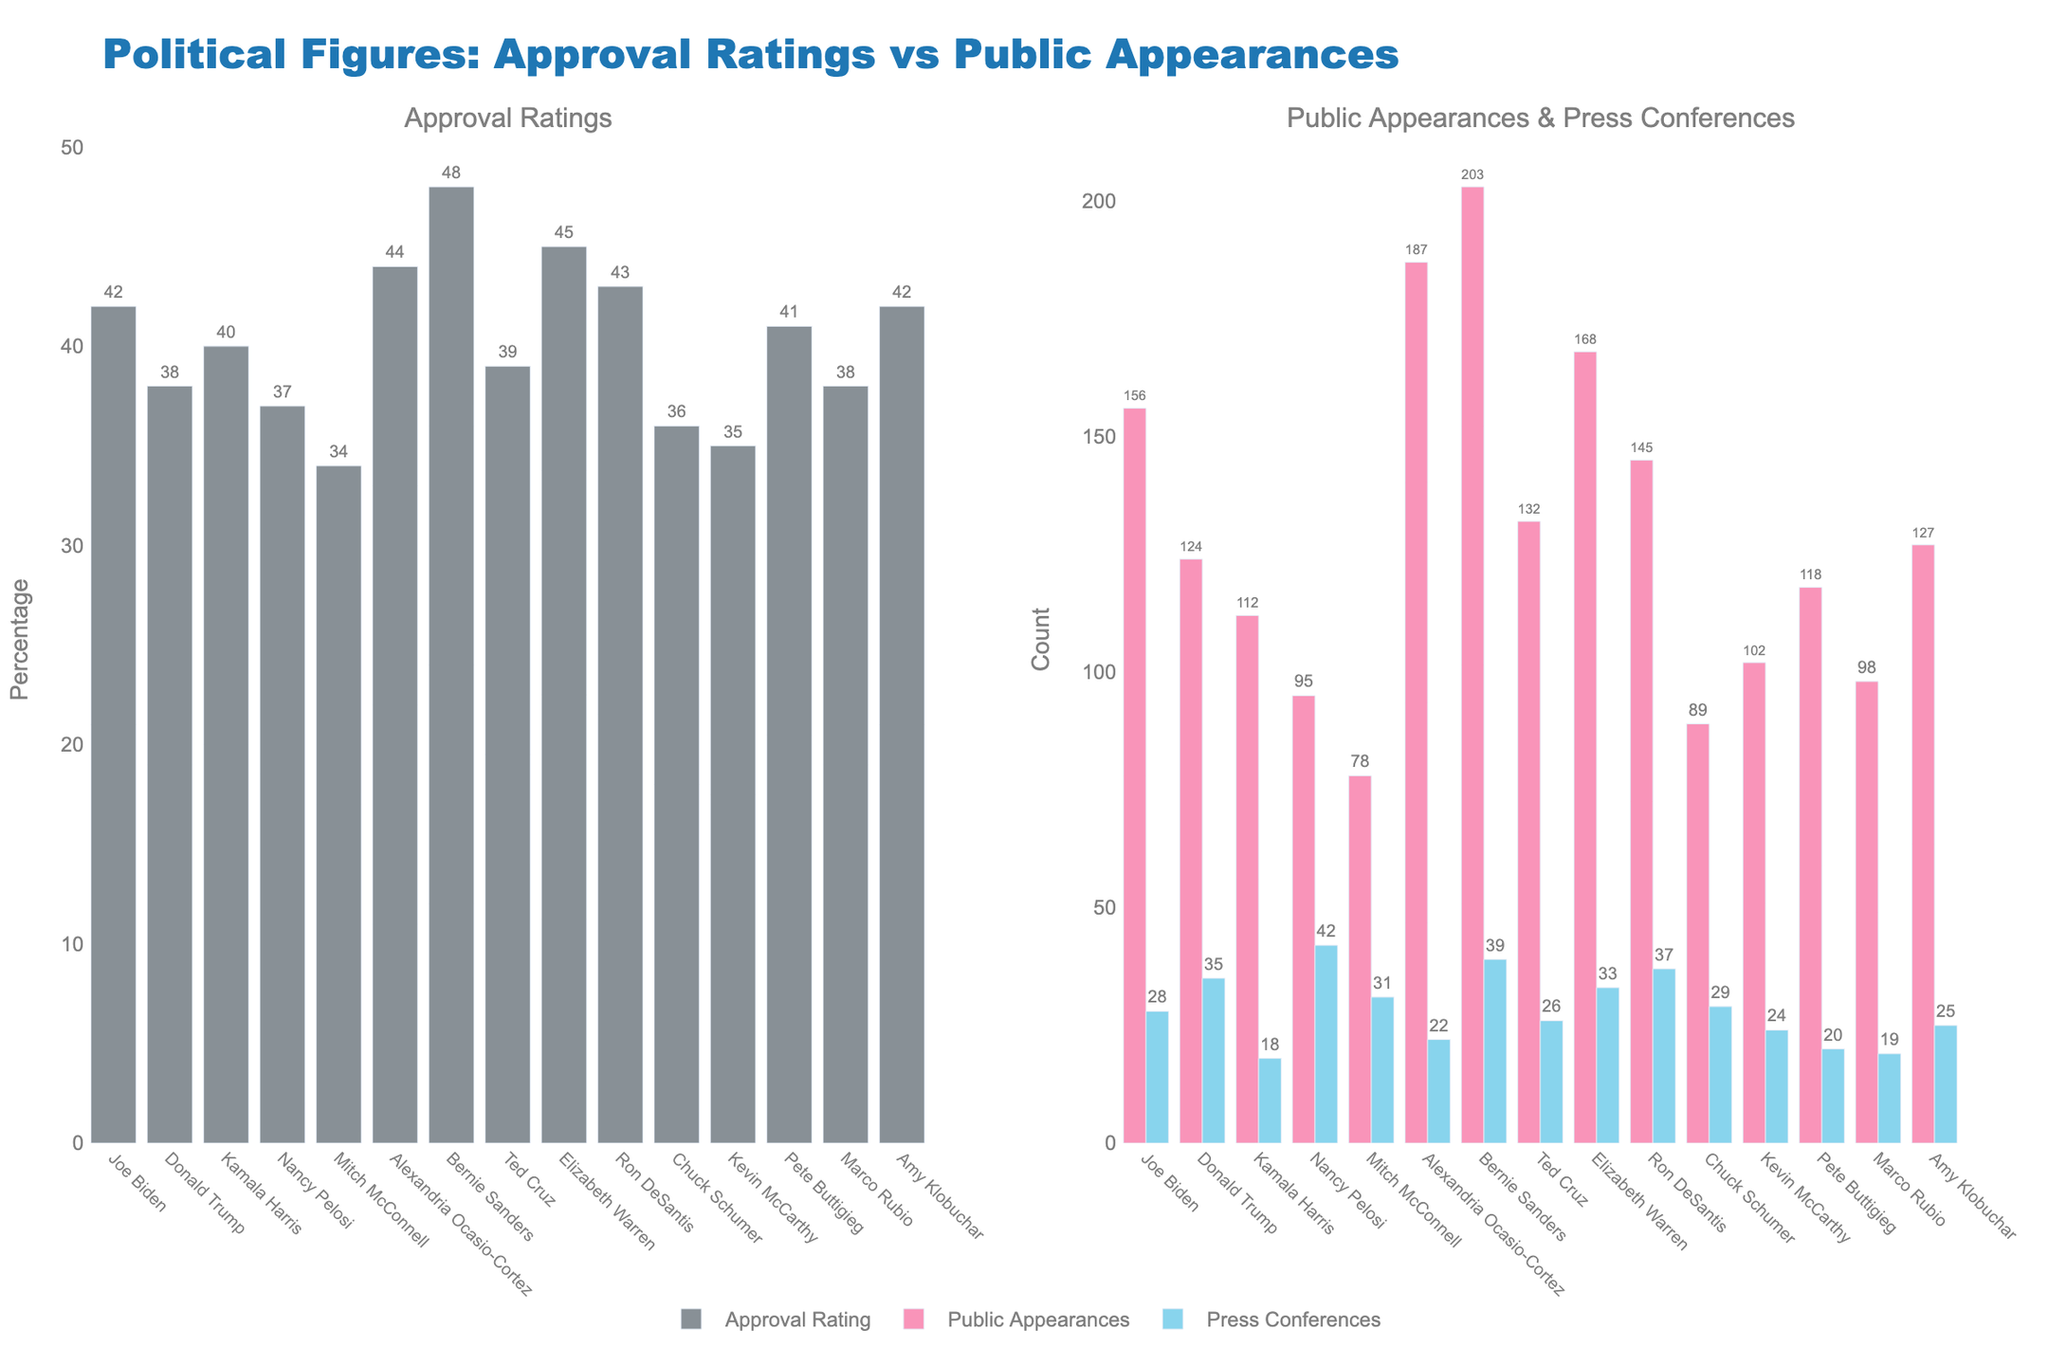What's the approval rating of the political figure with the most public appearances? To find this, locate the bar representing the highest number of public appearances in the right chart. The tallest bar is Bernie Sanders with 203 public appearances. Then check the approval rating for Bernie Sanders in the left chart.
Answer: 48% Which political figure has the smallest difference between public appearances and press conferences? First, calculate the difference between public appearances and press conferences for each political figure. Then find the smallest difference. For example, for Joe Biden: 156 - 28 = 128. Do this for all political figures. The smallest difference is for Pete Buttigieg, which is 118 - 20 = 98.
Answer: Pete Buttigieg Compare the approval ratings of Bernie Sanders and Joe Biden. Who has a higher rating and by how much? Look at the left chart to compare the approval ratings. Bernie Sanders has 48% and Joe Biden has 42%. Subtract Joe Biden's rating from Bernie Sanders' rating: 48% - 42% = 6%. So, Bernie Sanders has a higher rating by 6%.
Answer: Bernie Sanders by 6% Which color represents press conferences, and what is the highest value indicated by this color? The color representing press conferences is blue. Look for the highest blue bar in the right chart. The highest value is Bernie Sanders with 39 press conferences.
Answer: Blue, 39 Sum the total number of public appearances made by Donald Trump, Kamala Harris, and Mike Pence. Refer to the right chart for the public appearances of each figure. Donald Trump has 124, Kamala Harris has 112, and Mike Pence is not listed. Therefore, sum the numbers: 124 + 112 = 236.
Answer: 236 Who has a higher number of public appearances: Ted Cruz or Marco Rubio? Compare the bars for Ted Cruz and Marco Rubio in the right chart. Ted Cruz has 132 public appearances and Marco Rubio has 98. Thus, Ted Cruz has a higher number of public appearances.
Answer: Ted Cruz What's the average approval rating of the listed political figures? Add all the approval ratings together and divide by the number of figures. Sum: 42 + 38 + 40 + 37 + 34 + 44 + 48 + 39 + 45 + 43 + 36 + 35 + 41 + 38 + 42 = 602. There are 15 figures, so the average is 602 / 15 = 40.13%.
Answer: 40.13% Which political figure has the lowest press conference count, and what is the value? Identify the shortest blue bar in the right chart. Kamala Harris has the lowest press conference count with 18.
Answer: Kamala Harris, 18 